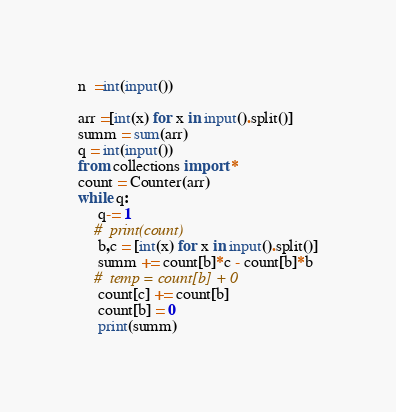<code> <loc_0><loc_0><loc_500><loc_500><_Python_>n  =int(input())

arr =[int(x) for x in input().split()]
summ = sum(arr)
q = int(input())
from collections import *
count = Counter(arr)
while q:
     q-= 1
    #  print(count)
     b,c = [int(x) for x in input().split()]
     summ += count[b]*c - count[b]*b
    #  temp = count[b] + 0
     count[c] += count[b]
     count[b] = 0
     print(summ)</code> 